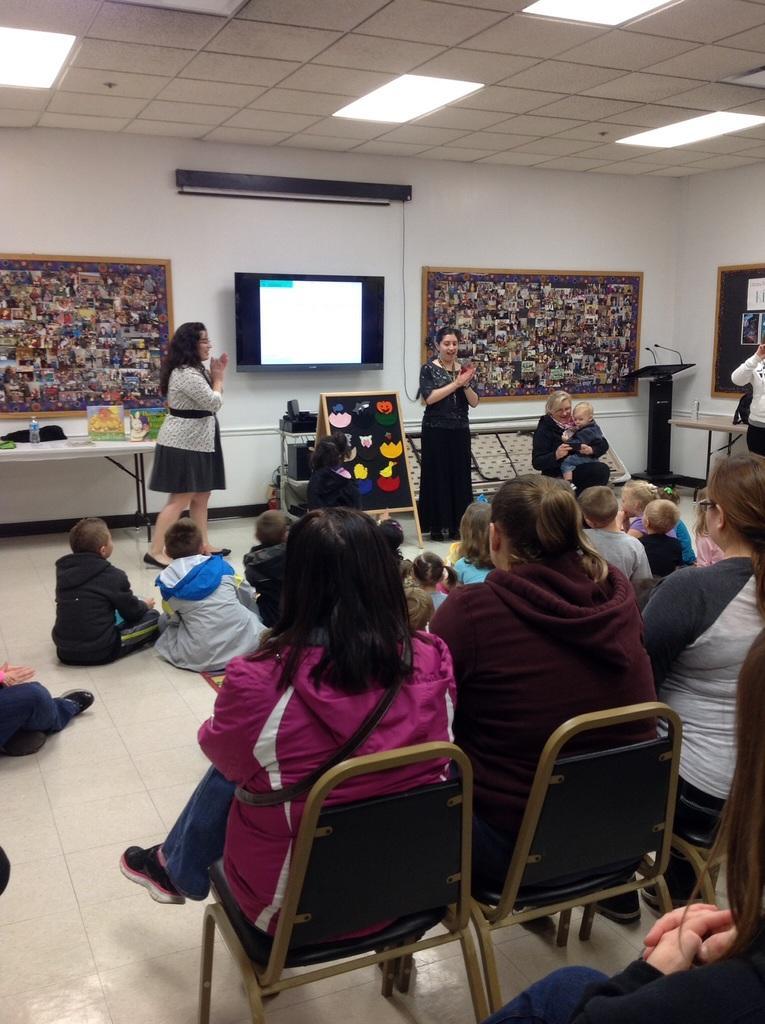Could you give a brief overview of what you see in this image? In this picture we can see two woman standing and clapping their hands and beside to the other woman sitting on chair holding child in her hands and in front of them we have a group of people some are sitting on chairs and some are sitting on floors and in background we can see wall, screen, frames, podium with mics, table, bottle. 